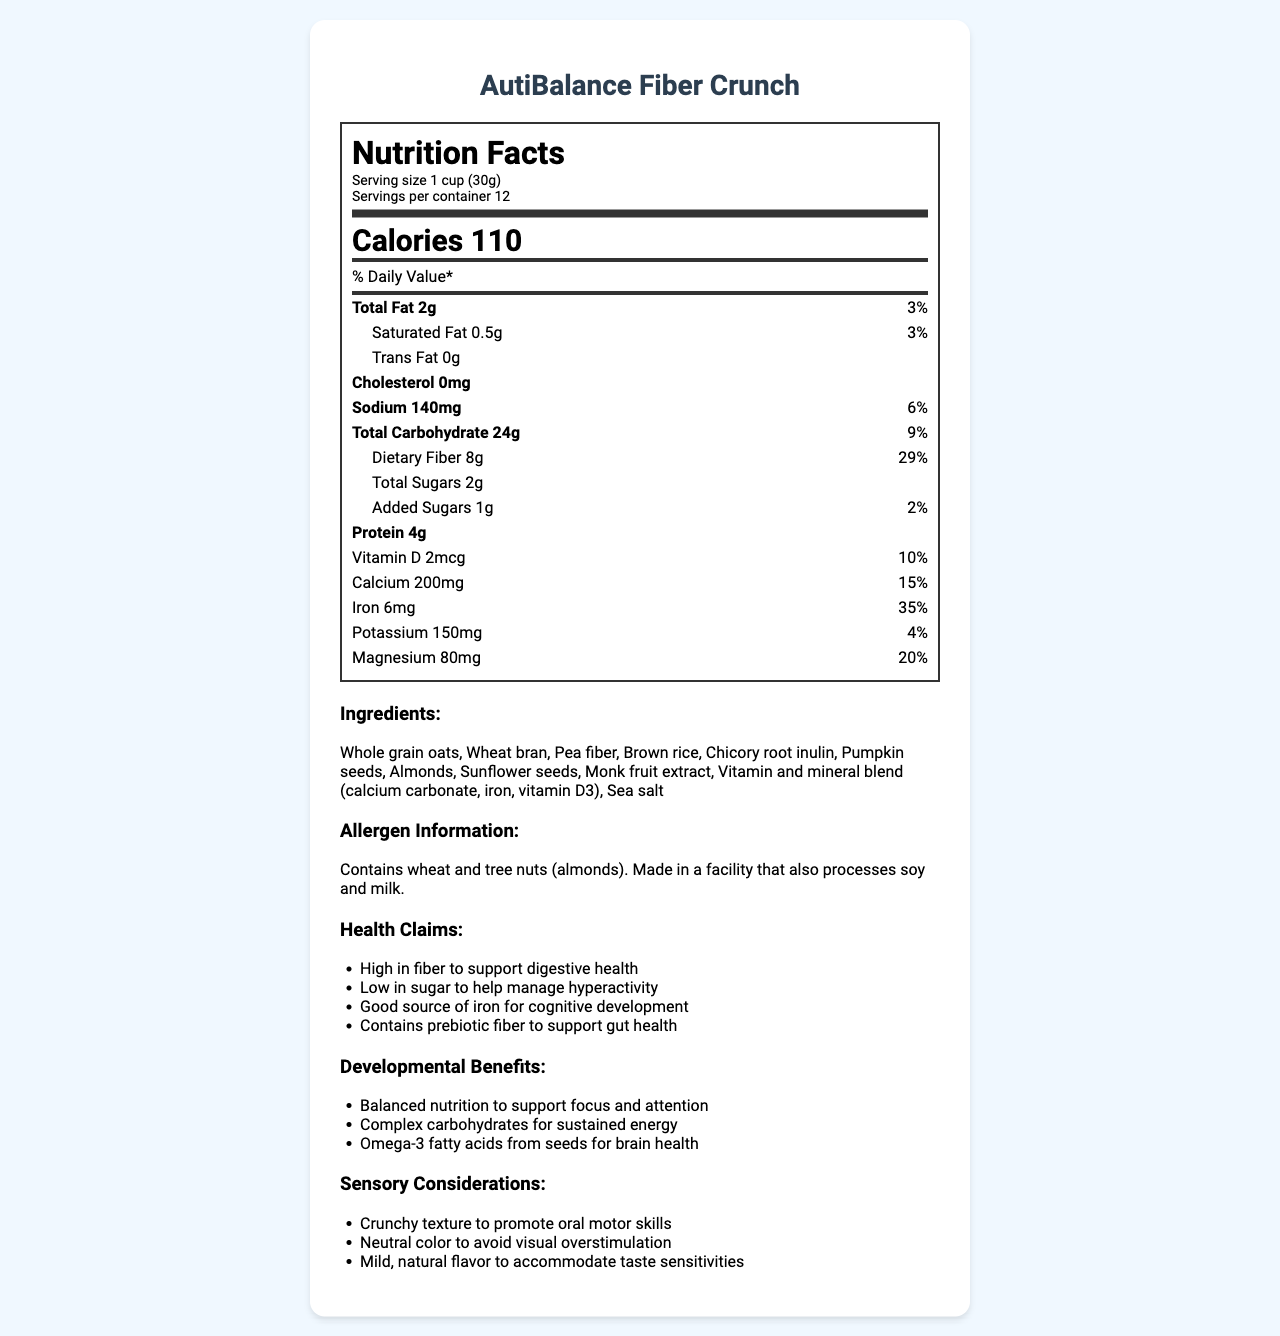what is the serving size? The serving size is clearly stated at the top of the nutrition label: “Serving size 1 cup (30g).”
Answer: 1 cup (30g) how many calories are in one serving? The calories per serving are prominently displayed in large font: “Calories 110.”
Answer: 110 calories what percentage of daily value does dietary fiber represent? The daily value percentage for dietary fiber is provided: "Dietary Fiber 8g, 29%."
Answer: 29% how much protein is in one serving? The amount of protein per serving is listed: "Protein 4g."
Answer: 4g what are the main ingredients in this cereal? The ingredients are enumerated in the ingredients section after the nutrition facts.
Answer: Whole grain oats, Wheat bran, Pea fiber, Brown rice, Chicory root inulin, Pumpkin seeds, Almonds, Sunflower seeds, Monk fruit extract, Vitamin and mineral blend (calcium carbonate, iron, vitamin D3), Sea salt which of the following is NOT an ingredient in this cereal? A. Whole grain oats B. Pea fiber C. Corn syrup D. Pumpkin seeds The ingredient list does not mention corn syrup, while the other options are listed.
Answer: C. Corn syrup how much iron is provided per serving? The amount of iron is listed as "Iron 6mg."
Answer: 6mg what is the prebiotic fiber in this cereal? Chicory root inulin is listed in the ingredients and noted for its prebiotic benefits in the health claims section.
Answer: Chicory root inulin is this cereal gluten-free? The allergen information states: "Contains wheat and tree nuts (almonds)."
Answer: No describe the main idea of this document The document outlines detailed facts about the cereal including serving size, vitamins, minerals, and other nutritional components, as well as additional benefits and considerations relevant to its target audience.
Answer: The document provides the nutritional information, ingredients, health claims, developmental benefits, and sensory considerations for the low-sugar, high-fiber cereal product "AutiBalance Fiber Crunch," aiming to support the digestive health and reduce hyperactivity in autistic children. what is the amount of total fat in one serving? The nutrition facts label under "Total Fat" lists "2g."
Answer: 2g how many servings are there per container? The servings per container are listed at the top of the nutrition facts: "Servings per container 12."
Answer: 12 which of the following is a health claim made by this product? A. Supports heart health B. Gluten-free C. Contains prebiotic fiber to support gut health D. Low calorie The health claims section includes "Contains prebiotic fiber to support gut health."
Answer: C. Contains prebiotic fiber to support gut health does the information indicate the potential improvement of oral motor skills? One of the sensory considerations is "Crunchy texture to promote oral motor skills."
Answer: Yes what is the main sweetener used in this cereal? The ingredients list "Monk fruit extract" as the sweetener used.
Answer: Monk fruit extract how much total carbohydrate does one serving provide? The total carbohydrate amount is listed as "24g" in the nutrition facts label.
Answer: 24g does this product contain any cholesterol? The nutrition label lists "Cholesterol 0mg," indicating there is no cholesterol.
Answer: No explain why this cereal might be beneficial for cognitive development in autistic children. Iron is crucial for cognitive development, as indicated by the high iron content (6mg, 35% daily value). Additionally, omega-3 fatty acids from seeds are known for their benefits to brain health, mentioned in the developmental benefits section.
Answer: The cereal is high in iron, which is essential for cognitive development. It also contains omega-3 fatty acids from seeds, which support brain health. how much sodium is there per serving? The nutrition facts specify "Sodium 140mg."
Answer: 140mg why might someone with soy or milk allergies need to be cautious with this cereal? The allergen information states: "Made in a facility that also processes soy and milk."
Answer: The allergen information notes that the cereal is made in a facility that also processes soy and milk, so cross-contamination is possible. is there any mention of vitamin C in the nutritional information? The nutrition facts do not list vitamin C, indicating it is not included or not significant enough to mention.
Answer: No what is the purpose of including pumpkin seeds and sunflower seeds in the ingredients? The developmental benefits section mentions that omega-3 fatty acids from seeds support brain health. Pumpkin seeds and sunflower seeds are sources of these fatty acids.
Answer: To provide omega-3 fatty acids for brain health. 